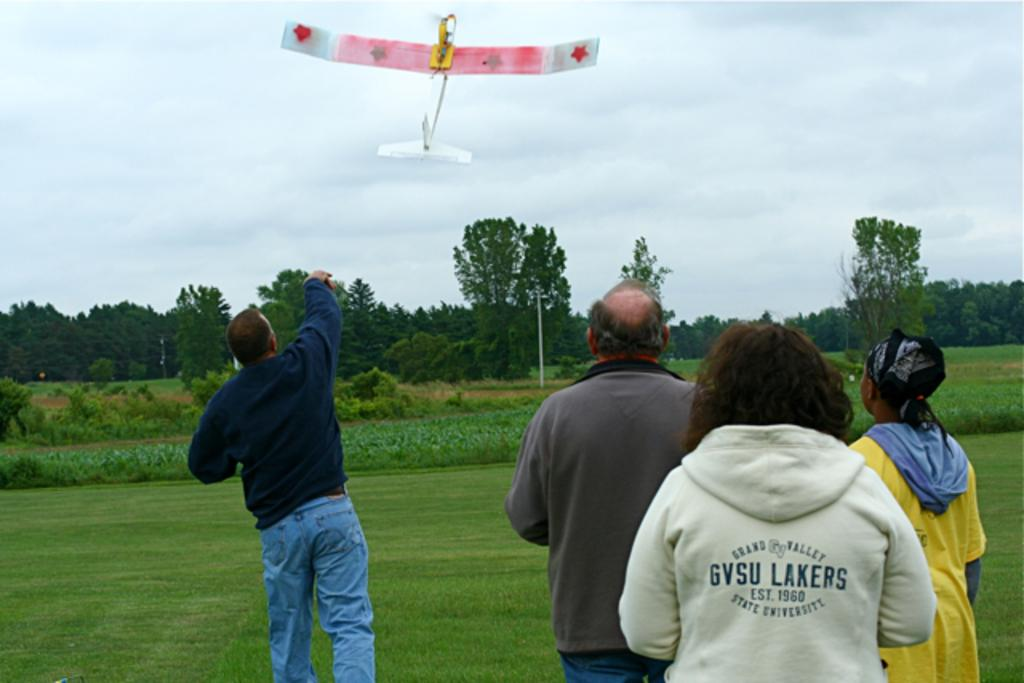<image>
Offer a succinct explanation of the picture presented. One of the people watching a man launch a model airplane by throwing it into the air is wearing a jacket from Grand Valley University. 